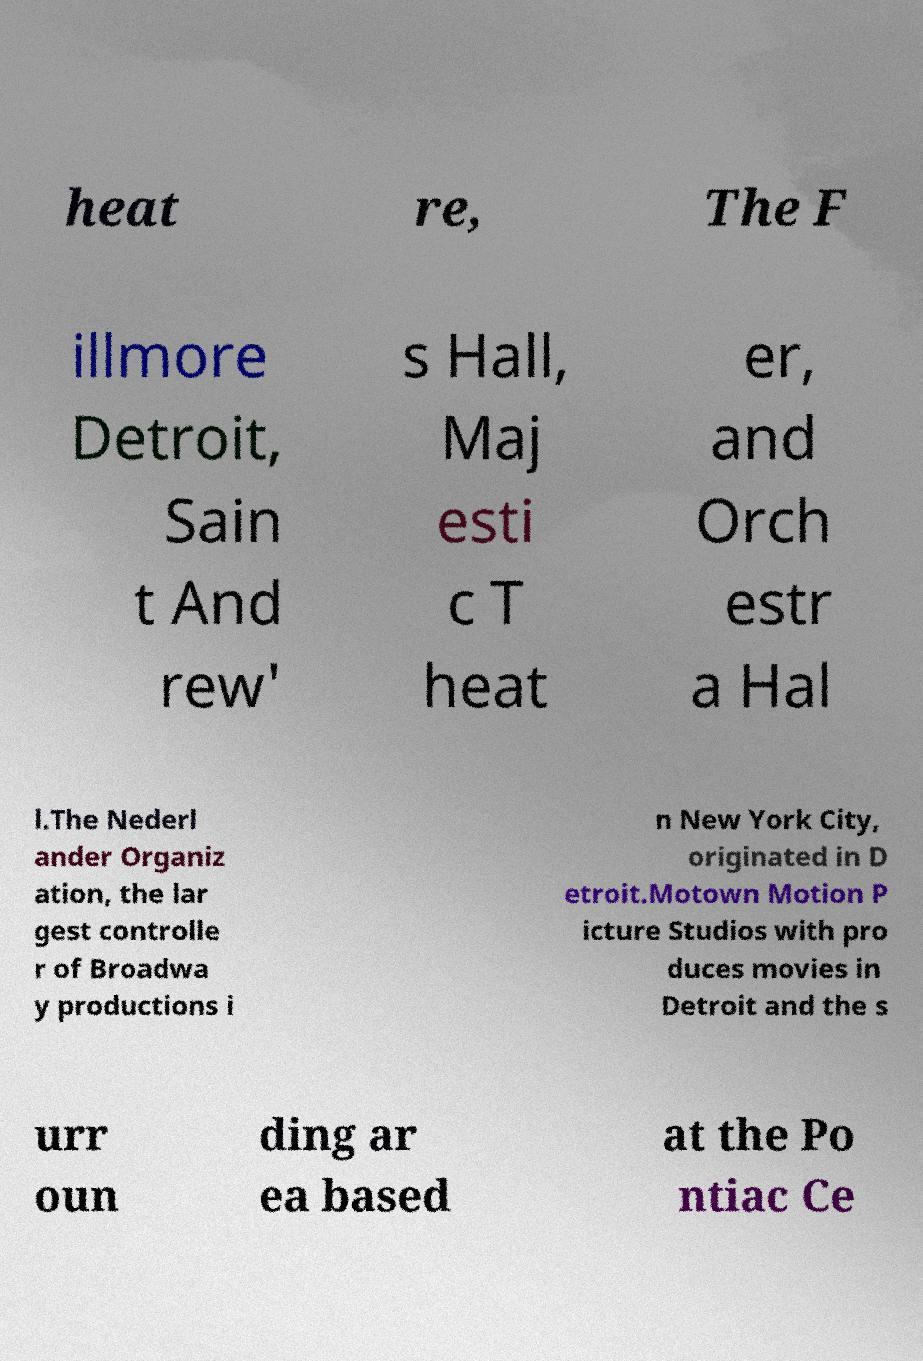Can you read and provide the text displayed in the image?This photo seems to have some interesting text. Can you extract and type it out for me? heat re, The F illmore Detroit, Sain t And rew' s Hall, Maj esti c T heat er, and Orch estr a Hal l.The Nederl ander Organiz ation, the lar gest controlle r of Broadwa y productions i n New York City, originated in D etroit.Motown Motion P icture Studios with pro duces movies in Detroit and the s urr oun ding ar ea based at the Po ntiac Ce 